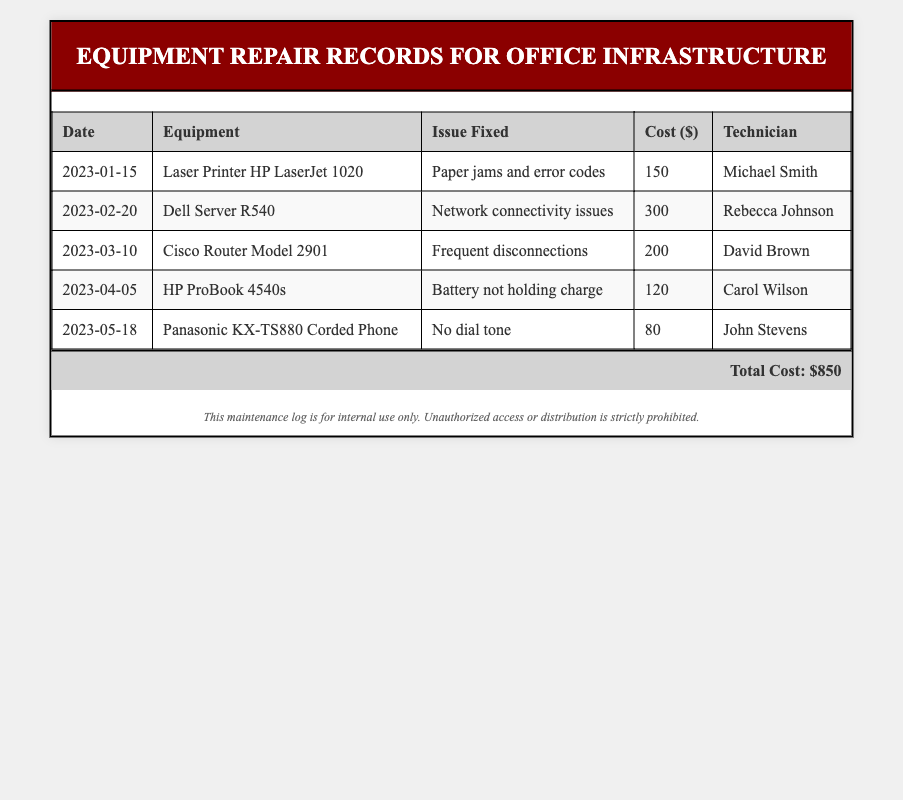What is the total cost of repairs? The total cost is displayed at the bottom of the document, summarizing all individual costs presented in the table.
Answer: $850 When was the laser printer repaired? The date of the laser printer repair can be found in the corresponding row in the table where the equipment is listed.
Answer: 2023-01-15 What issue was fixed for the Dell Server? The specific issue related to the Dell Server is listed under the "Issue Fixed" column of the table.
Answer: Network connectivity issues Who repaired the HP ProBook? The technician responsible for repairing the HP ProBook can be found in the last column of its corresponding row in the table.
Answer: Carol Wilson How much did it cost to fix the Panasonic phone? The cost associated with the Panasonic phone repair is indicated in the table under the "Cost" column.
Answer: 80 